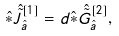Convert formula to latex. <formula><loc_0><loc_0><loc_500><loc_500>\hat { \ast } \hat { \tilde { J } } ^ { [ 1 ] } _ { \hat { a } } = d \hat { \ast } \hat { \tilde { G } } ^ { [ 2 ] } _ { \hat { a } } ,</formula> 